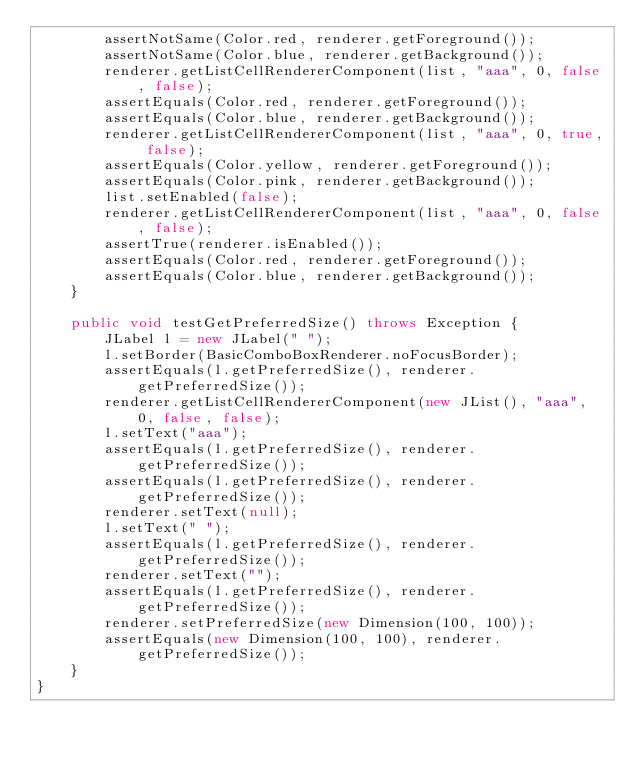<code> <loc_0><loc_0><loc_500><loc_500><_Java_>        assertNotSame(Color.red, renderer.getForeground());
        assertNotSame(Color.blue, renderer.getBackground());
        renderer.getListCellRendererComponent(list, "aaa", 0, false, false);
        assertEquals(Color.red, renderer.getForeground());
        assertEquals(Color.blue, renderer.getBackground());
        renderer.getListCellRendererComponent(list, "aaa", 0, true, false);
        assertEquals(Color.yellow, renderer.getForeground());
        assertEquals(Color.pink, renderer.getBackground());
        list.setEnabled(false);
        renderer.getListCellRendererComponent(list, "aaa", 0, false, false);
        assertTrue(renderer.isEnabled());
        assertEquals(Color.red, renderer.getForeground());
        assertEquals(Color.blue, renderer.getBackground());
    }

    public void testGetPreferredSize() throws Exception {
        JLabel l = new JLabel(" ");
        l.setBorder(BasicComboBoxRenderer.noFocusBorder);
        assertEquals(l.getPreferredSize(), renderer.getPreferredSize());
        renderer.getListCellRendererComponent(new JList(), "aaa", 0, false, false);
        l.setText("aaa");
        assertEquals(l.getPreferredSize(), renderer.getPreferredSize());
        assertEquals(l.getPreferredSize(), renderer.getPreferredSize());
        renderer.setText(null);
        l.setText(" ");
        assertEquals(l.getPreferredSize(), renderer.getPreferredSize());
        renderer.setText("");
        assertEquals(l.getPreferredSize(), renderer.getPreferredSize());
        renderer.setPreferredSize(new Dimension(100, 100));
        assertEquals(new Dimension(100, 100), renderer.getPreferredSize());
    }
}
</code> 